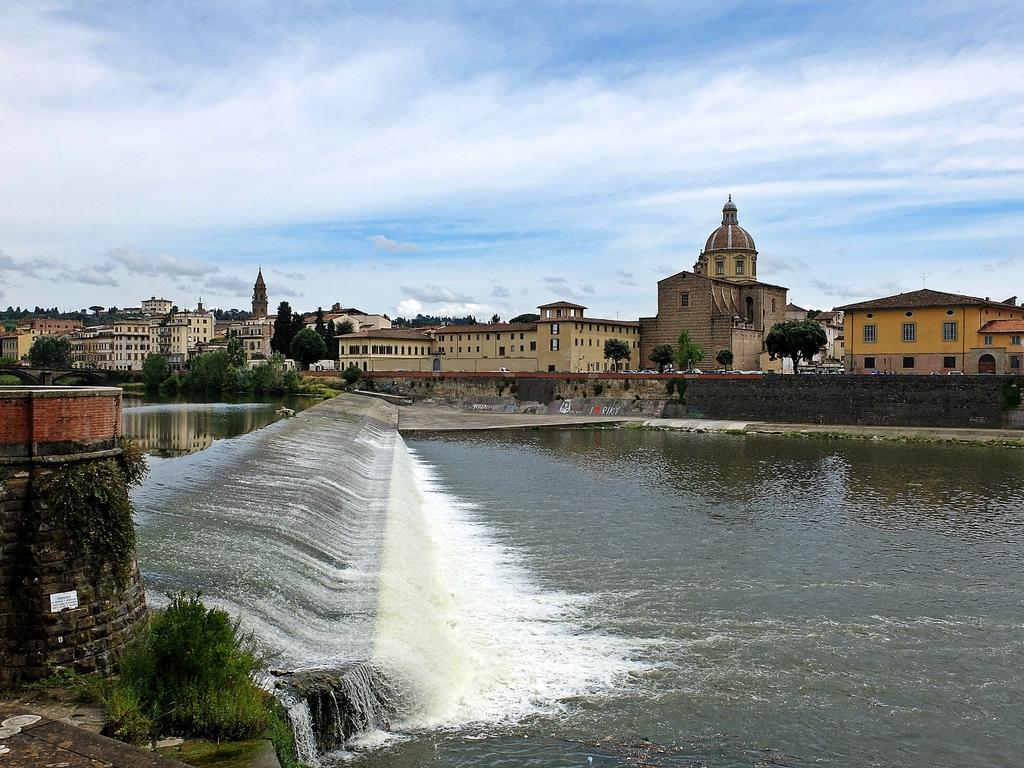Describe this image in one or two sentences. Here we can see water, plants, wall, trees, and buildings. In the background there is sky with clouds. 